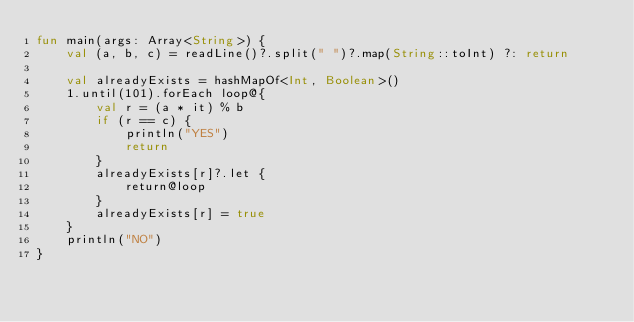<code> <loc_0><loc_0><loc_500><loc_500><_Kotlin_>fun main(args: Array<String>) {
    val (a, b, c) = readLine()?.split(" ")?.map(String::toInt) ?: return

    val alreadyExists = hashMapOf<Int, Boolean>()
    1.until(101).forEach loop@{
        val r = (a * it) % b
        if (r == c) {
            println("YES")
            return
        }
        alreadyExists[r]?.let {
            return@loop
        }
        alreadyExists[r] = true
    }
    println("NO")
}</code> 